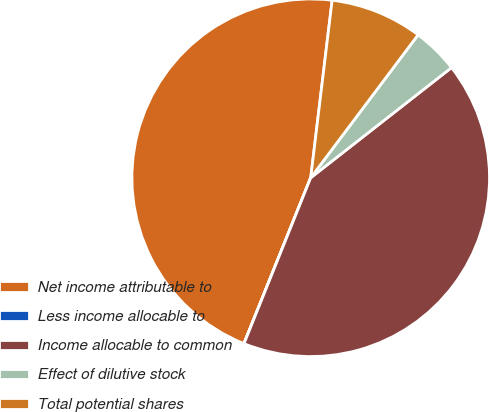Convert chart. <chart><loc_0><loc_0><loc_500><loc_500><pie_chart><fcel>Net income attributable to<fcel>Less income allocable to<fcel>Income allocable to common<fcel>Effect of dilutive stock<fcel>Total potential shares<nl><fcel>45.82%<fcel>0.01%<fcel>41.65%<fcel>4.18%<fcel>8.34%<nl></chart> 